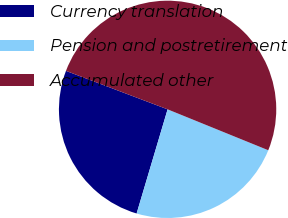Convert chart to OTSL. <chart><loc_0><loc_0><loc_500><loc_500><pie_chart><fcel>Currency translation<fcel>Pension and postretirement<fcel>Accumulated other<nl><fcel>26.16%<fcel>23.46%<fcel>50.38%<nl></chart> 